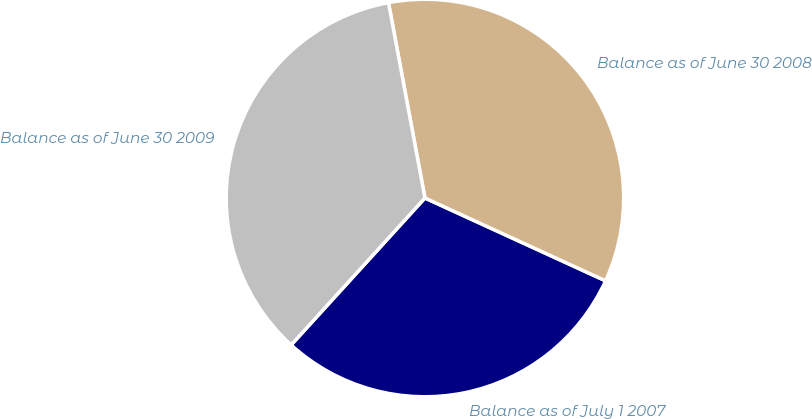<chart> <loc_0><loc_0><loc_500><loc_500><pie_chart><fcel>Balance as of July 1 2007<fcel>Balance as of June 30 2008<fcel>Balance as of June 30 2009<nl><fcel>29.91%<fcel>34.78%<fcel>35.31%<nl></chart> 